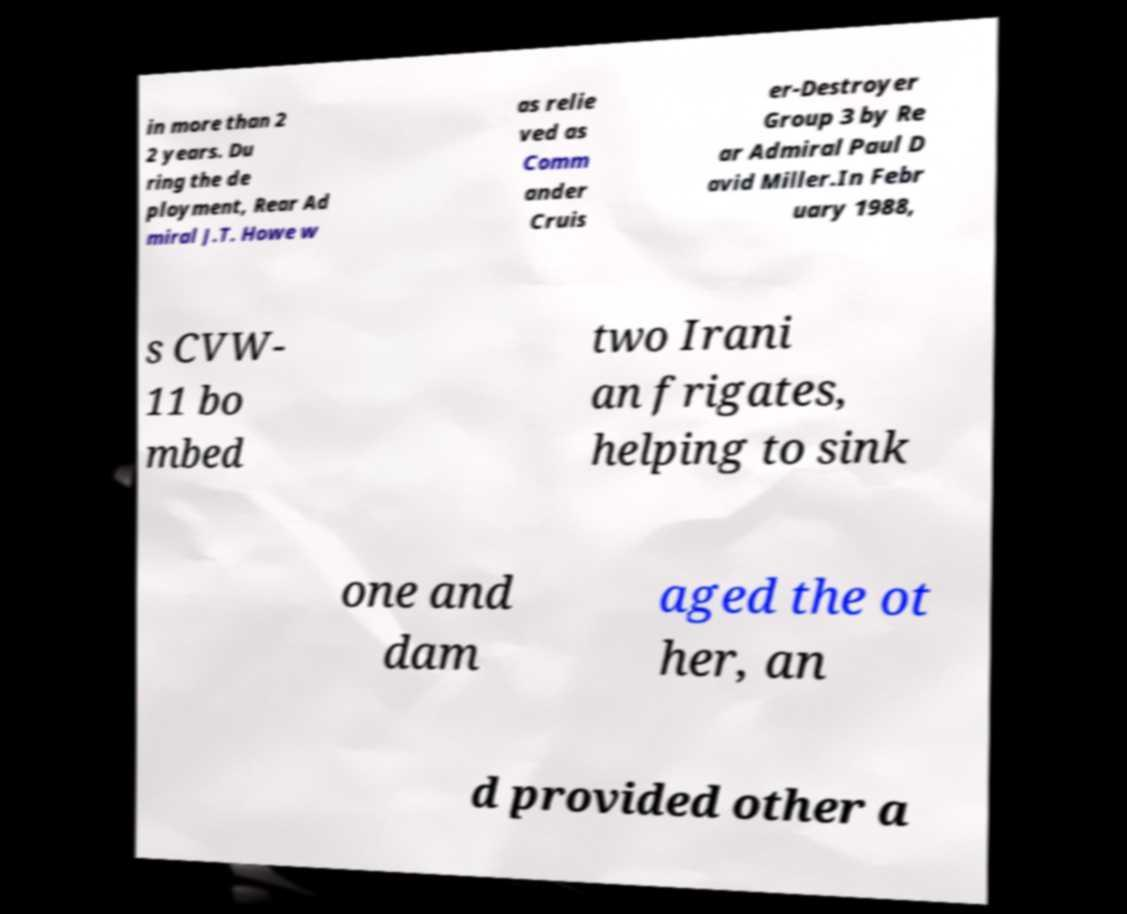What messages or text are displayed in this image? I need them in a readable, typed format. in more than 2 2 years. Du ring the de ployment, Rear Ad miral J.T. Howe w as relie ved as Comm ander Cruis er-Destroyer Group 3 by Re ar Admiral Paul D avid Miller.In Febr uary 1988, s CVW- 11 bo mbed two Irani an frigates, helping to sink one and dam aged the ot her, an d provided other a 